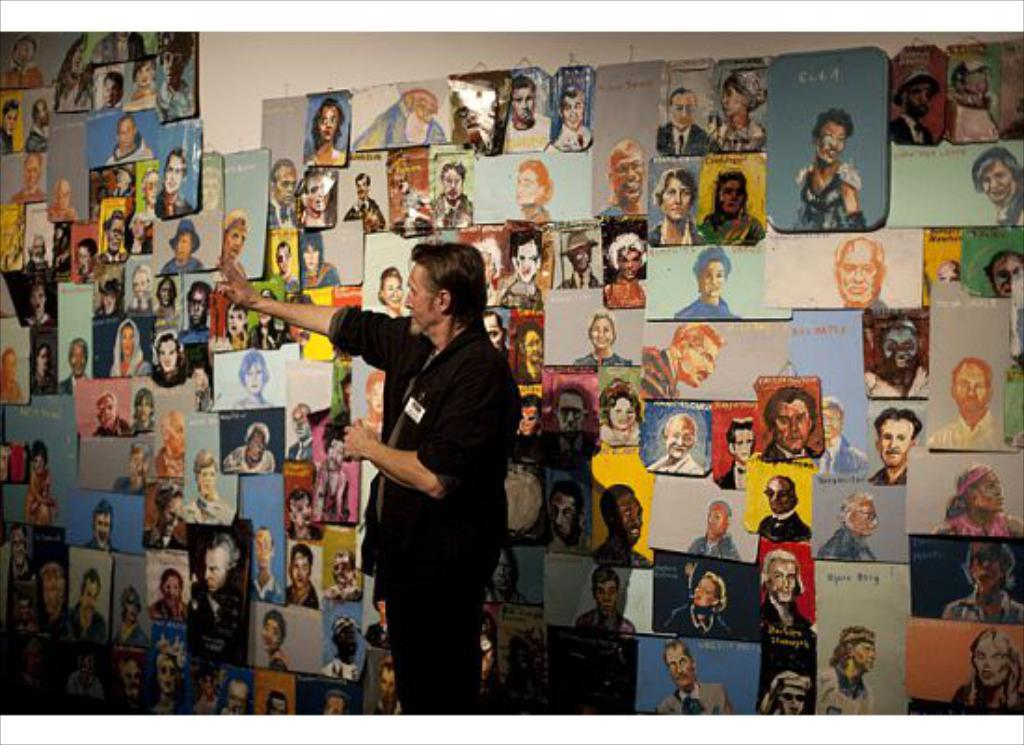Who is present in the image? There is a man in the image. What can be seen in the background of the image? There are posts on a wall in the background of the image. What type of toothbrush does the man's uncle use? There is no toothbrush or uncle mentioned in the image, so it is not possible to answer that question. 